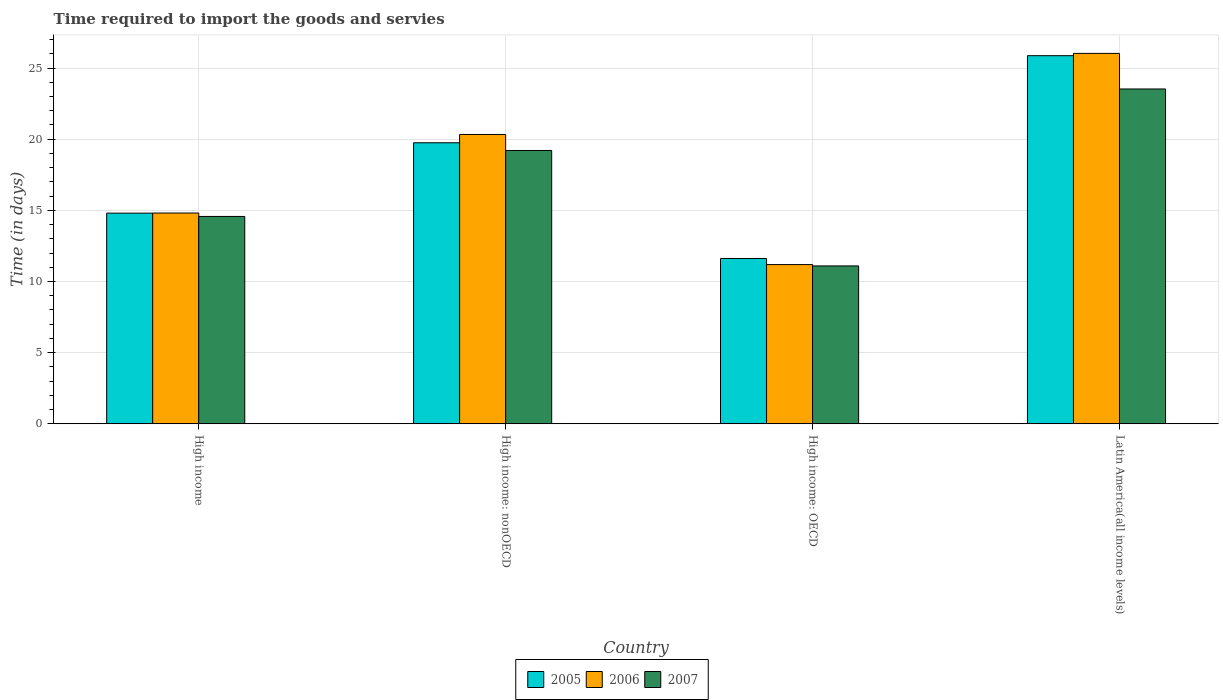How many different coloured bars are there?
Your answer should be compact. 3. How many groups of bars are there?
Provide a short and direct response. 4. Are the number of bars on each tick of the X-axis equal?
Your answer should be very brief. Yes. How many bars are there on the 3rd tick from the right?
Make the answer very short. 3. What is the label of the 3rd group of bars from the left?
Keep it short and to the point. High income: OECD. What is the number of days required to import the goods and services in 2007 in High income: nonOECD?
Keep it short and to the point. 19.21. Across all countries, what is the maximum number of days required to import the goods and services in 2006?
Your response must be concise. 26.03. Across all countries, what is the minimum number of days required to import the goods and services in 2007?
Your response must be concise. 11.09. In which country was the number of days required to import the goods and services in 2005 maximum?
Make the answer very short. Latin America(all income levels). In which country was the number of days required to import the goods and services in 2006 minimum?
Offer a very short reply. High income: OECD. What is the total number of days required to import the goods and services in 2007 in the graph?
Your answer should be compact. 68.4. What is the difference between the number of days required to import the goods and services in 2007 in High income: OECD and that in High income: nonOECD?
Keep it short and to the point. -8.11. What is the difference between the number of days required to import the goods and services in 2006 in High income: nonOECD and the number of days required to import the goods and services in 2007 in High income: OECD?
Your answer should be very brief. 9.24. What is the average number of days required to import the goods and services in 2006 per country?
Your answer should be very brief. 18.09. What is the difference between the number of days required to import the goods and services of/in 2007 and number of days required to import the goods and services of/in 2006 in High income: OECD?
Offer a very short reply. -0.09. In how many countries, is the number of days required to import the goods and services in 2005 greater than 3 days?
Offer a terse response. 4. What is the ratio of the number of days required to import the goods and services in 2007 in High income to that in Latin America(all income levels)?
Offer a terse response. 0.62. Is the number of days required to import the goods and services in 2007 in High income less than that in High income: OECD?
Provide a succinct answer. No. What is the difference between the highest and the second highest number of days required to import the goods and services in 2006?
Your response must be concise. 5.7. What is the difference between the highest and the lowest number of days required to import the goods and services in 2006?
Ensure brevity in your answer.  14.84. What does the 3rd bar from the left in High income represents?
Offer a very short reply. 2007. Is it the case that in every country, the sum of the number of days required to import the goods and services in 2007 and number of days required to import the goods and services in 2006 is greater than the number of days required to import the goods and services in 2005?
Your answer should be compact. Yes. Are all the bars in the graph horizontal?
Keep it short and to the point. No. What is the difference between two consecutive major ticks on the Y-axis?
Give a very brief answer. 5. Are the values on the major ticks of Y-axis written in scientific E-notation?
Your response must be concise. No. Does the graph contain any zero values?
Your answer should be compact. No. Does the graph contain grids?
Your response must be concise. Yes. Where does the legend appear in the graph?
Offer a terse response. Bottom center. How many legend labels are there?
Ensure brevity in your answer.  3. How are the legend labels stacked?
Your answer should be very brief. Horizontal. What is the title of the graph?
Offer a very short reply. Time required to import the goods and servies. What is the label or title of the X-axis?
Ensure brevity in your answer.  Country. What is the label or title of the Y-axis?
Offer a very short reply. Time (in days). What is the Time (in days) in 2005 in High income?
Offer a terse response. 14.8. What is the Time (in days) in 2006 in High income?
Keep it short and to the point. 14.81. What is the Time (in days) of 2007 in High income?
Your answer should be very brief. 14.57. What is the Time (in days) of 2005 in High income: nonOECD?
Provide a succinct answer. 19.75. What is the Time (in days) in 2006 in High income: nonOECD?
Your answer should be very brief. 20.33. What is the Time (in days) of 2007 in High income: nonOECD?
Give a very brief answer. 19.21. What is the Time (in days) in 2005 in High income: OECD?
Your answer should be compact. 11.61. What is the Time (in days) in 2006 in High income: OECD?
Your answer should be compact. 11.19. What is the Time (in days) of 2007 in High income: OECD?
Provide a short and direct response. 11.09. What is the Time (in days) in 2005 in Latin America(all income levels)?
Make the answer very short. 25.87. What is the Time (in days) in 2006 in Latin America(all income levels)?
Your response must be concise. 26.03. What is the Time (in days) in 2007 in Latin America(all income levels)?
Offer a terse response. 23.53. Across all countries, what is the maximum Time (in days) of 2005?
Offer a terse response. 25.87. Across all countries, what is the maximum Time (in days) of 2006?
Offer a very short reply. 26.03. Across all countries, what is the maximum Time (in days) in 2007?
Ensure brevity in your answer.  23.53. Across all countries, what is the minimum Time (in days) in 2005?
Your response must be concise. 11.61. Across all countries, what is the minimum Time (in days) in 2006?
Keep it short and to the point. 11.19. Across all countries, what is the minimum Time (in days) in 2007?
Your answer should be compact. 11.09. What is the total Time (in days) in 2005 in the graph?
Keep it short and to the point. 72.04. What is the total Time (in days) of 2006 in the graph?
Your answer should be compact. 72.36. What is the total Time (in days) in 2007 in the graph?
Give a very brief answer. 68.4. What is the difference between the Time (in days) in 2005 in High income and that in High income: nonOECD?
Offer a terse response. -4.95. What is the difference between the Time (in days) in 2006 in High income and that in High income: nonOECD?
Offer a terse response. -5.52. What is the difference between the Time (in days) in 2007 in High income and that in High income: nonOECD?
Provide a short and direct response. -4.64. What is the difference between the Time (in days) in 2005 in High income and that in High income: OECD?
Your response must be concise. 3.19. What is the difference between the Time (in days) of 2006 in High income and that in High income: OECD?
Offer a very short reply. 3.62. What is the difference between the Time (in days) in 2007 in High income and that in High income: OECD?
Provide a short and direct response. 3.48. What is the difference between the Time (in days) in 2005 in High income and that in Latin America(all income levels)?
Offer a very short reply. -11.07. What is the difference between the Time (in days) in 2006 in High income and that in Latin America(all income levels)?
Your response must be concise. -11.22. What is the difference between the Time (in days) in 2007 in High income and that in Latin America(all income levels)?
Keep it short and to the point. -8.96. What is the difference between the Time (in days) of 2005 in High income: nonOECD and that in High income: OECD?
Make the answer very short. 8.14. What is the difference between the Time (in days) in 2006 in High income: nonOECD and that in High income: OECD?
Your answer should be compact. 9.15. What is the difference between the Time (in days) of 2007 in High income: nonOECD and that in High income: OECD?
Give a very brief answer. 8.11. What is the difference between the Time (in days) of 2005 in High income: nonOECD and that in Latin America(all income levels)?
Your answer should be very brief. -6.12. What is the difference between the Time (in days) of 2006 in High income: nonOECD and that in Latin America(all income levels)?
Provide a short and direct response. -5.7. What is the difference between the Time (in days) of 2007 in High income: nonOECD and that in Latin America(all income levels)?
Provide a succinct answer. -4.32. What is the difference between the Time (in days) of 2005 in High income: OECD and that in Latin America(all income levels)?
Give a very brief answer. -14.26. What is the difference between the Time (in days) of 2006 in High income: OECD and that in Latin America(all income levels)?
Offer a terse response. -14.84. What is the difference between the Time (in days) of 2007 in High income: OECD and that in Latin America(all income levels)?
Your answer should be compact. -12.44. What is the difference between the Time (in days) in 2005 in High income and the Time (in days) in 2006 in High income: nonOECD?
Your answer should be very brief. -5.53. What is the difference between the Time (in days) of 2005 in High income and the Time (in days) of 2007 in High income: nonOECD?
Your answer should be very brief. -4.4. What is the difference between the Time (in days) in 2006 in High income and the Time (in days) in 2007 in High income: nonOECD?
Offer a terse response. -4.4. What is the difference between the Time (in days) of 2005 in High income and the Time (in days) of 2006 in High income: OECD?
Make the answer very short. 3.62. What is the difference between the Time (in days) of 2005 in High income and the Time (in days) of 2007 in High income: OECD?
Provide a short and direct response. 3.71. What is the difference between the Time (in days) of 2006 in High income and the Time (in days) of 2007 in High income: OECD?
Make the answer very short. 3.72. What is the difference between the Time (in days) of 2005 in High income and the Time (in days) of 2006 in Latin America(all income levels)?
Your answer should be compact. -11.23. What is the difference between the Time (in days) in 2005 in High income and the Time (in days) in 2007 in Latin America(all income levels)?
Your answer should be compact. -8.73. What is the difference between the Time (in days) of 2006 in High income and the Time (in days) of 2007 in Latin America(all income levels)?
Give a very brief answer. -8.72. What is the difference between the Time (in days) of 2005 in High income: nonOECD and the Time (in days) of 2006 in High income: OECD?
Provide a short and direct response. 8.56. What is the difference between the Time (in days) of 2005 in High income: nonOECD and the Time (in days) of 2007 in High income: OECD?
Provide a succinct answer. 8.66. What is the difference between the Time (in days) in 2006 in High income: nonOECD and the Time (in days) in 2007 in High income: OECD?
Your response must be concise. 9.24. What is the difference between the Time (in days) of 2005 in High income: nonOECD and the Time (in days) of 2006 in Latin America(all income levels)?
Offer a very short reply. -6.28. What is the difference between the Time (in days) of 2005 in High income: nonOECD and the Time (in days) of 2007 in Latin America(all income levels)?
Provide a succinct answer. -3.78. What is the difference between the Time (in days) of 2006 in High income: nonOECD and the Time (in days) of 2007 in Latin America(all income levels)?
Your answer should be very brief. -3.2. What is the difference between the Time (in days) of 2005 in High income: OECD and the Time (in days) of 2006 in Latin America(all income levels)?
Your response must be concise. -14.42. What is the difference between the Time (in days) in 2005 in High income: OECD and the Time (in days) in 2007 in Latin America(all income levels)?
Give a very brief answer. -11.92. What is the difference between the Time (in days) of 2006 in High income: OECD and the Time (in days) of 2007 in Latin America(all income levels)?
Make the answer very short. -12.34. What is the average Time (in days) of 2005 per country?
Make the answer very short. 18.01. What is the average Time (in days) in 2006 per country?
Provide a succinct answer. 18.09. What is the average Time (in days) in 2007 per country?
Give a very brief answer. 17.1. What is the difference between the Time (in days) in 2005 and Time (in days) in 2006 in High income?
Offer a terse response. -0.01. What is the difference between the Time (in days) in 2005 and Time (in days) in 2007 in High income?
Provide a short and direct response. 0.23. What is the difference between the Time (in days) of 2006 and Time (in days) of 2007 in High income?
Provide a succinct answer. 0.24. What is the difference between the Time (in days) in 2005 and Time (in days) in 2006 in High income: nonOECD?
Your answer should be very brief. -0.58. What is the difference between the Time (in days) in 2005 and Time (in days) in 2007 in High income: nonOECD?
Ensure brevity in your answer.  0.54. What is the difference between the Time (in days) in 2006 and Time (in days) in 2007 in High income: nonOECD?
Offer a very short reply. 1.12. What is the difference between the Time (in days) of 2005 and Time (in days) of 2006 in High income: OECD?
Make the answer very short. 0.43. What is the difference between the Time (in days) of 2005 and Time (in days) of 2007 in High income: OECD?
Offer a terse response. 0.52. What is the difference between the Time (in days) in 2006 and Time (in days) in 2007 in High income: OECD?
Keep it short and to the point. 0.09. What is the difference between the Time (in days) of 2005 and Time (in days) of 2006 in Latin America(all income levels)?
Offer a very short reply. -0.16. What is the difference between the Time (in days) of 2005 and Time (in days) of 2007 in Latin America(all income levels)?
Your response must be concise. 2.34. What is the difference between the Time (in days) of 2006 and Time (in days) of 2007 in Latin America(all income levels)?
Give a very brief answer. 2.5. What is the ratio of the Time (in days) in 2005 in High income to that in High income: nonOECD?
Make the answer very short. 0.75. What is the ratio of the Time (in days) in 2006 in High income to that in High income: nonOECD?
Provide a succinct answer. 0.73. What is the ratio of the Time (in days) of 2007 in High income to that in High income: nonOECD?
Your answer should be very brief. 0.76. What is the ratio of the Time (in days) in 2005 in High income to that in High income: OECD?
Offer a very short reply. 1.27. What is the ratio of the Time (in days) of 2006 in High income to that in High income: OECD?
Your answer should be very brief. 1.32. What is the ratio of the Time (in days) of 2007 in High income to that in High income: OECD?
Ensure brevity in your answer.  1.31. What is the ratio of the Time (in days) in 2005 in High income to that in Latin America(all income levels)?
Offer a very short reply. 0.57. What is the ratio of the Time (in days) of 2006 in High income to that in Latin America(all income levels)?
Your answer should be compact. 0.57. What is the ratio of the Time (in days) of 2007 in High income to that in Latin America(all income levels)?
Offer a terse response. 0.62. What is the ratio of the Time (in days) of 2005 in High income: nonOECD to that in High income: OECD?
Your response must be concise. 1.7. What is the ratio of the Time (in days) in 2006 in High income: nonOECD to that in High income: OECD?
Ensure brevity in your answer.  1.82. What is the ratio of the Time (in days) in 2007 in High income: nonOECD to that in High income: OECD?
Provide a short and direct response. 1.73. What is the ratio of the Time (in days) of 2005 in High income: nonOECD to that in Latin America(all income levels)?
Your response must be concise. 0.76. What is the ratio of the Time (in days) in 2006 in High income: nonOECD to that in Latin America(all income levels)?
Make the answer very short. 0.78. What is the ratio of the Time (in days) in 2007 in High income: nonOECD to that in Latin America(all income levels)?
Keep it short and to the point. 0.82. What is the ratio of the Time (in days) of 2005 in High income: OECD to that in Latin America(all income levels)?
Keep it short and to the point. 0.45. What is the ratio of the Time (in days) in 2006 in High income: OECD to that in Latin America(all income levels)?
Your response must be concise. 0.43. What is the ratio of the Time (in days) in 2007 in High income: OECD to that in Latin America(all income levels)?
Provide a succinct answer. 0.47. What is the difference between the highest and the second highest Time (in days) in 2005?
Ensure brevity in your answer.  6.12. What is the difference between the highest and the second highest Time (in days) in 2006?
Make the answer very short. 5.7. What is the difference between the highest and the second highest Time (in days) of 2007?
Make the answer very short. 4.32. What is the difference between the highest and the lowest Time (in days) in 2005?
Give a very brief answer. 14.26. What is the difference between the highest and the lowest Time (in days) in 2006?
Make the answer very short. 14.84. What is the difference between the highest and the lowest Time (in days) in 2007?
Give a very brief answer. 12.44. 